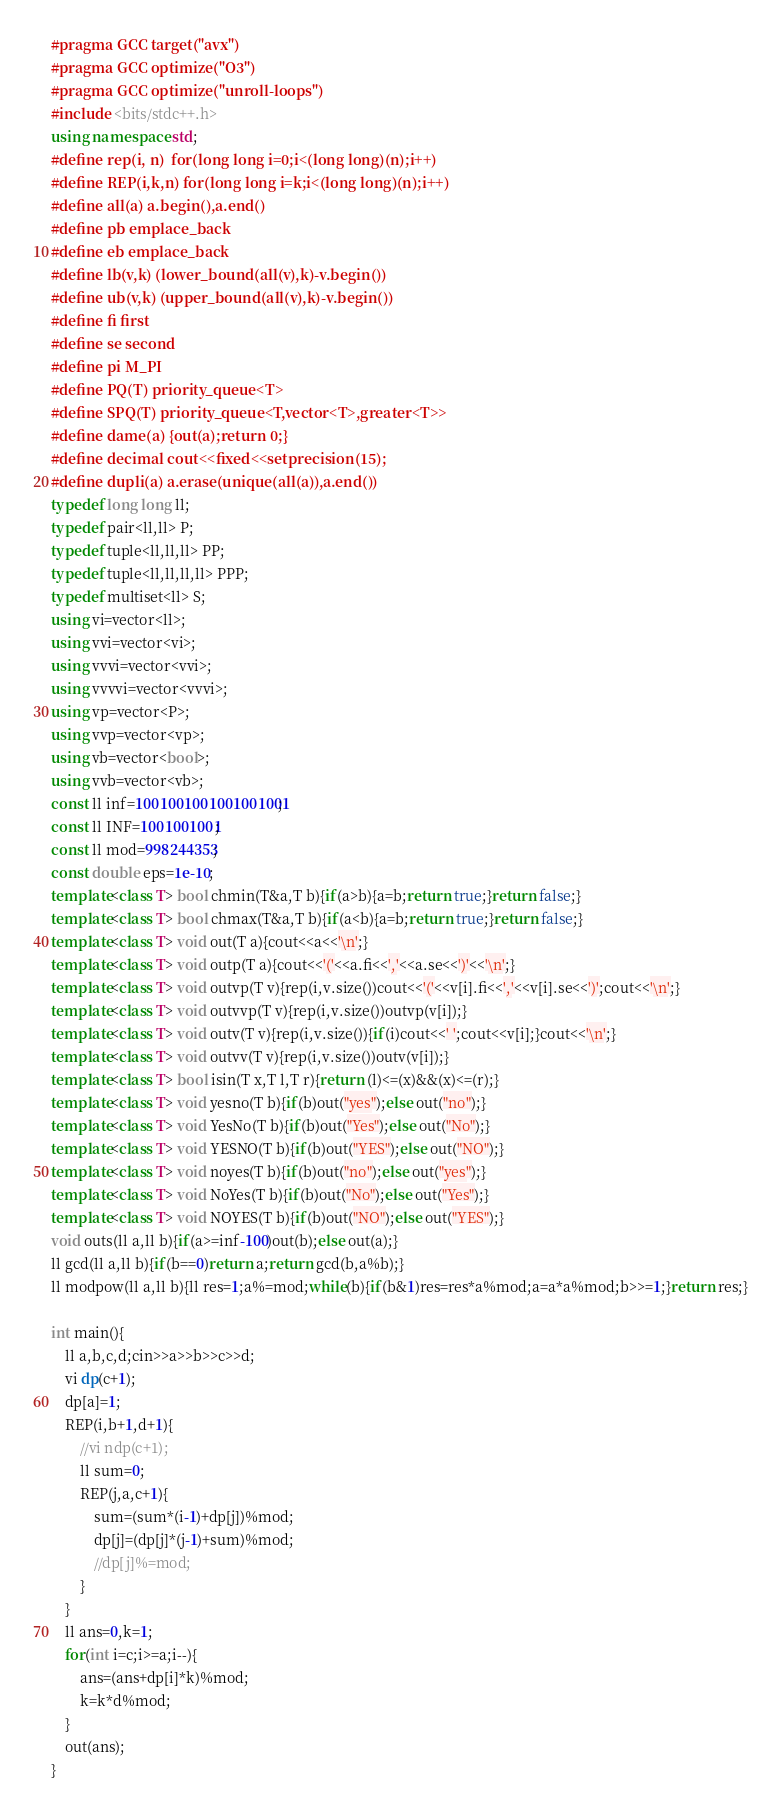<code> <loc_0><loc_0><loc_500><loc_500><_C++_>#pragma GCC target("avx")
#pragma GCC optimize("O3")
#pragma GCC optimize("unroll-loops")
#include <bits/stdc++.h>
using namespace std;
#define rep(i, n)  for(long long i=0;i<(long long)(n);i++)
#define REP(i,k,n) for(long long i=k;i<(long long)(n);i++)
#define all(a) a.begin(),a.end()
#define pb emplace_back
#define eb emplace_back
#define lb(v,k) (lower_bound(all(v),k)-v.begin())
#define ub(v,k) (upper_bound(all(v),k)-v.begin())
#define fi first
#define se second
#define pi M_PI
#define PQ(T) priority_queue<T>
#define SPQ(T) priority_queue<T,vector<T>,greater<T>>
#define dame(a) {out(a);return 0;}
#define decimal cout<<fixed<<setprecision(15);
#define dupli(a) a.erase(unique(all(a)),a.end())
typedef long long ll;
typedef pair<ll,ll> P;
typedef tuple<ll,ll,ll> PP;
typedef tuple<ll,ll,ll,ll> PPP;
typedef multiset<ll> S;
using vi=vector<ll>;
using vvi=vector<vi>;
using vvvi=vector<vvi>;
using vvvvi=vector<vvvi>;
using vp=vector<P>;
using vvp=vector<vp>;
using vb=vector<bool>;
using vvb=vector<vb>;
const ll inf=1001001001001001001;
const ll INF=1001001001;
const ll mod=998244353;
const double eps=1e-10;
template<class T> bool chmin(T&a,T b){if(a>b){a=b;return true;}return false;}
template<class T> bool chmax(T&a,T b){if(a<b){a=b;return true;}return false;}
template<class T> void out(T a){cout<<a<<'\n';}
template<class T> void outp(T a){cout<<'('<<a.fi<<','<<a.se<<')'<<'\n';}
template<class T> void outvp(T v){rep(i,v.size())cout<<'('<<v[i].fi<<','<<v[i].se<<')';cout<<'\n';}
template<class T> void outvvp(T v){rep(i,v.size())outvp(v[i]);}
template<class T> void outv(T v){rep(i,v.size()){if(i)cout<<' ';cout<<v[i];}cout<<'\n';}
template<class T> void outvv(T v){rep(i,v.size())outv(v[i]);}
template<class T> bool isin(T x,T l,T r){return (l)<=(x)&&(x)<=(r);}
template<class T> void yesno(T b){if(b)out("yes");else out("no");}
template<class T> void YesNo(T b){if(b)out("Yes");else out("No");}
template<class T> void YESNO(T b){if(b)out("YES");else out("NO");}
template<class T> void noyes(T b){if(b)out("no");else out("yes");}
template<class T> void NoYes(T b){if(b)out("No");else out("Yes");}
template<class T> void NOYES(T b){if(b)out("NO");else out("YES");}
void outs(ll a,ll b){if(a>=inf-100)out(b);else out(a);}
ll gcd(ll a,ll b){if(b==0)return a;return gcd(b,a%b);}
ll modpow(ll a,ll b){ll res=1;a%=mod;while(b){if(b&1)res=res*a%mod;a=a*a%mod;b>>=1;}return res;}

int main(){
    ll a,b,c,d;cin>>a>>b>>c>>d;
    vi dp(c+1);
    dp[a]=1;
    REP(i,b+1,d+1){
        //vi ndp(c+1);
        ll sum=0;
        REP(j,a,c+1){
            sum=(sum*(i-1)+dp[j])%mod;
            dp[j]=(dp[j]*(j-1)+sum)%mod;
            //dp[j]%=mod;
        }
    }
    ll ans=0,k=1;
    for(int i=c;i>=a;i--){
        ans=(ans+dp[i]*k)%mod;
        k=k*d%mod;
    }
    out(ans);
}</code> 